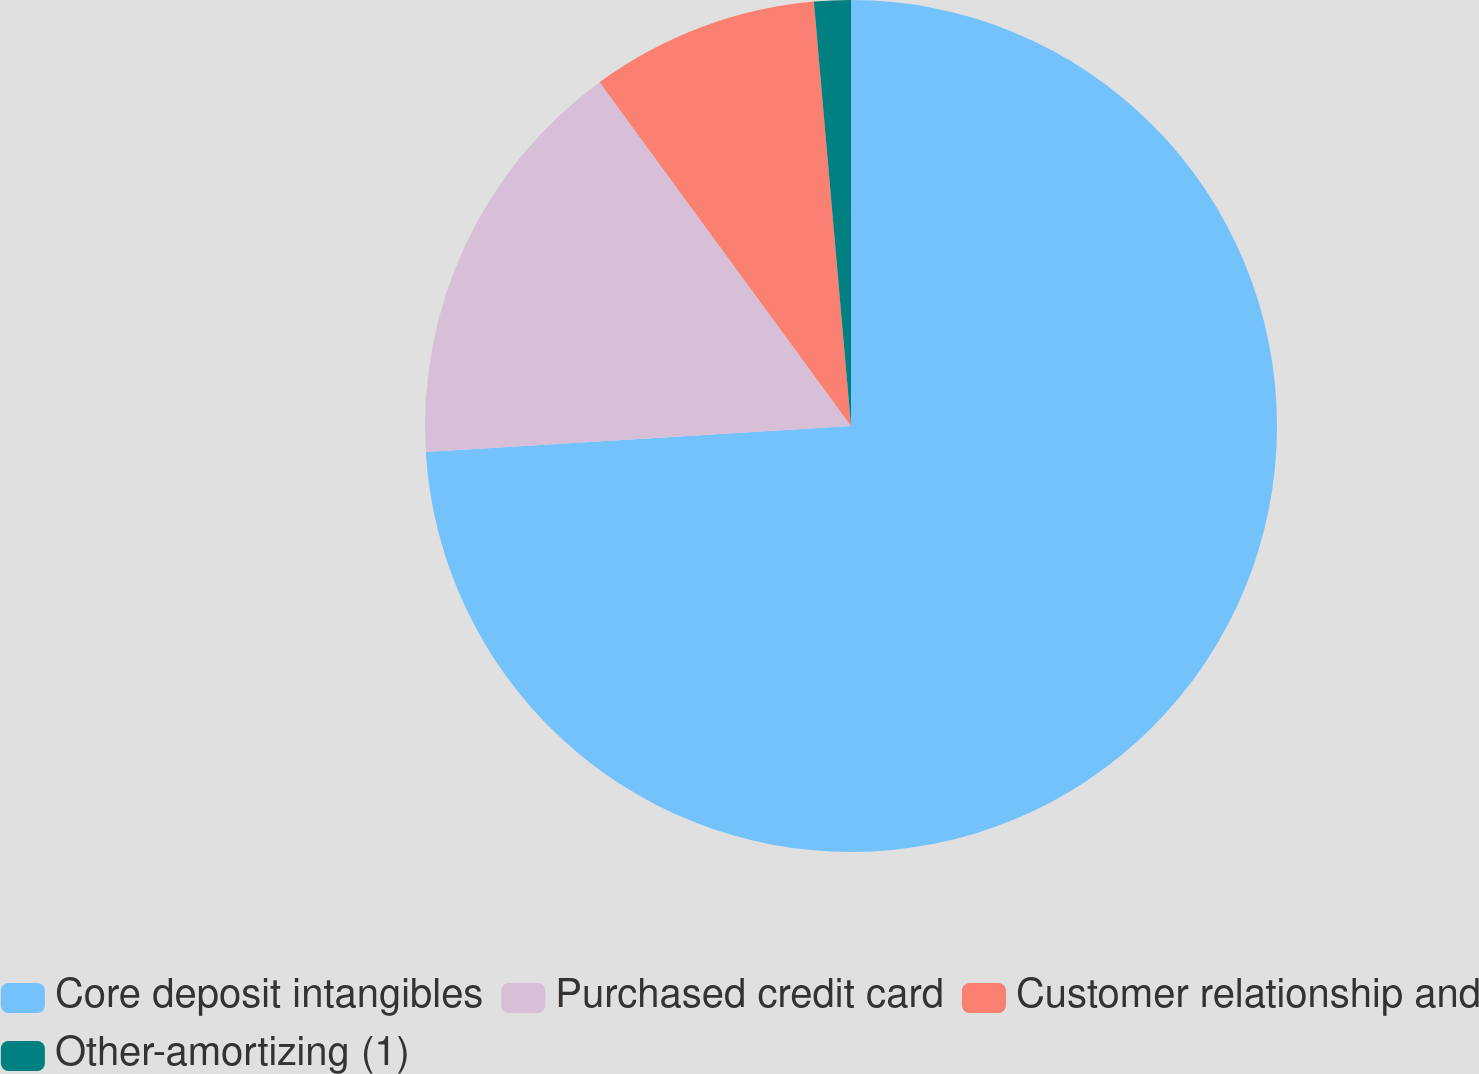Convert chart. <chart><loc_0><loc_0><loc_500><loc_500><pie_chart><fcel>Core deposit intangibles<fcel>Purchased credit card<fcel>Customer relationship and<fcel>Other-amortizing (1)<nl><fcel>74.03%<fcel>15.92%<fcel>8.66%<fcel>1.39%<nl></chart> 